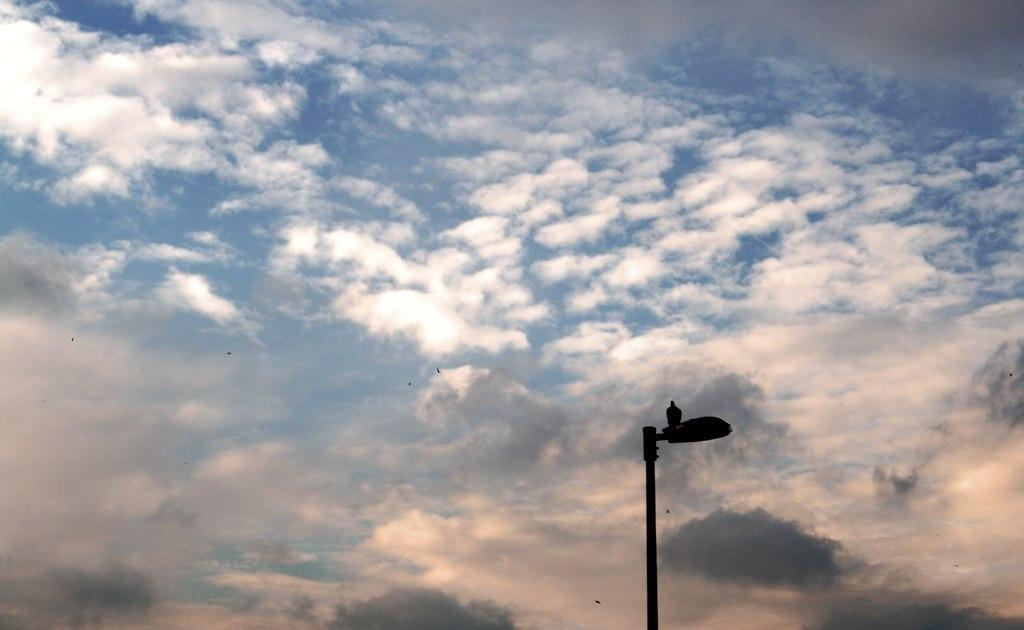What is the main subject of the image? There is a bird on a light pole in the image. What can be seen in the background of the image? The background of the image includes clouds. What is the color of the sky in the image? The sky is blue in color. What type of book is the bird holding in the image? There is no book present in the image; it features a bird on a light pole with a blue sky and clouds in the background. 